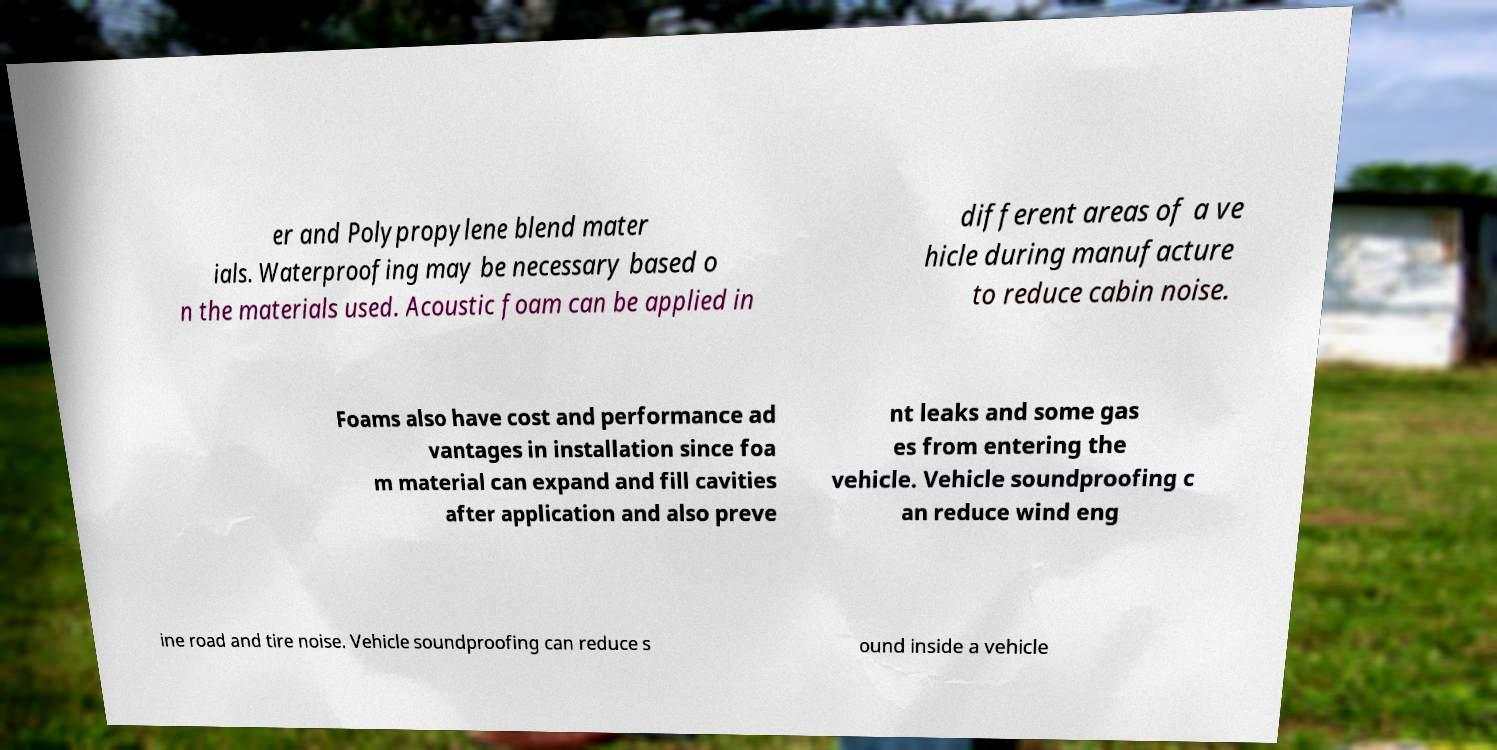Can you read and provide the text displayed in the image?This photo seems to have some interesting text. Can you extract and type it out for me? er and Polypropylene blend mater ials. Waterproofing may be necessary based o n the materials used. Acoustic foam can be applied in different areas of a ve hicle during manufacture to reduce cabin noise. Foams also have cost and performance ad vantages in installation since foa m material can expand and fill cavities after application and also preve nt leaks and some gas es from entering the vehicle. Vehicle soundproofing c an reduce wind eng ine road and tire noise. Vehicle soundproofing can reduce s ound inside a vehicle 